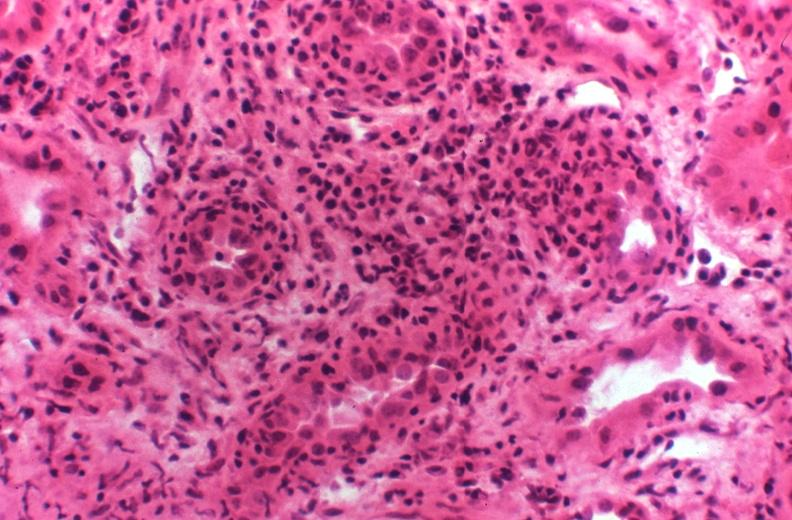does normal newborn show kidney transplant rejection?
Answer the question using a single word or phrase. No 